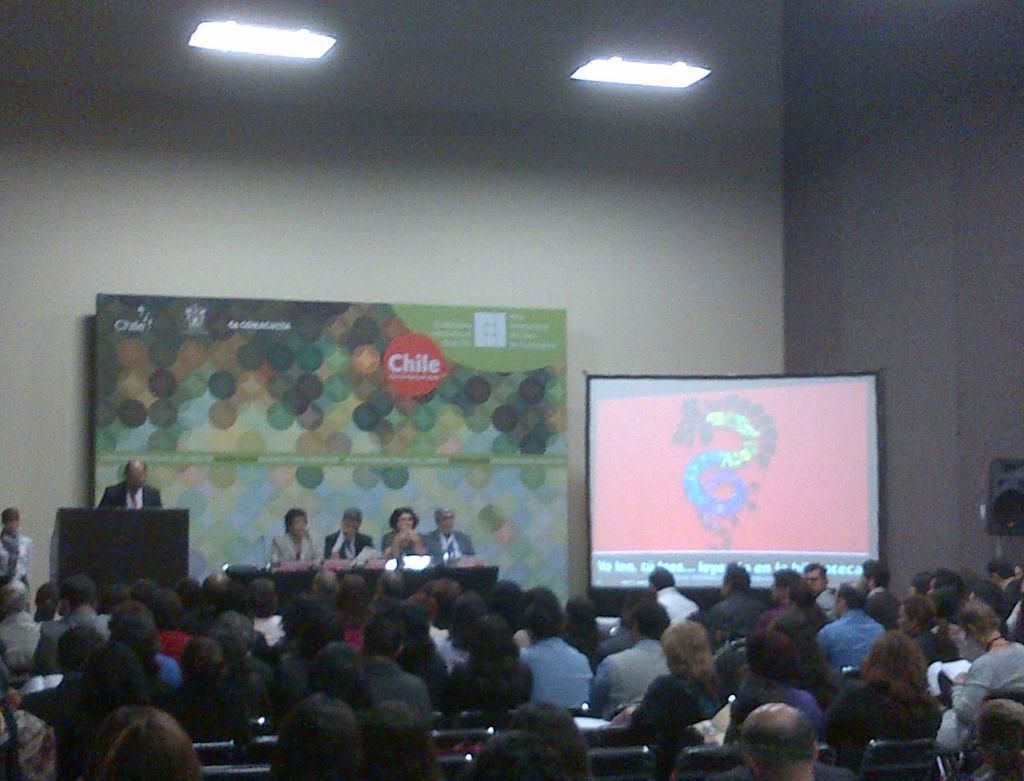Please provide a concise description of this image. In this image at the bottom there are some group of people who are sitting on chairs, and in the center there are some people who are sitting. In front of them there is a table, and one person is standing. In front of him there is one podium, and on the right side there is a screen and in the center there is one board. In the background there is wall and at the top there is ceiling and lights. 